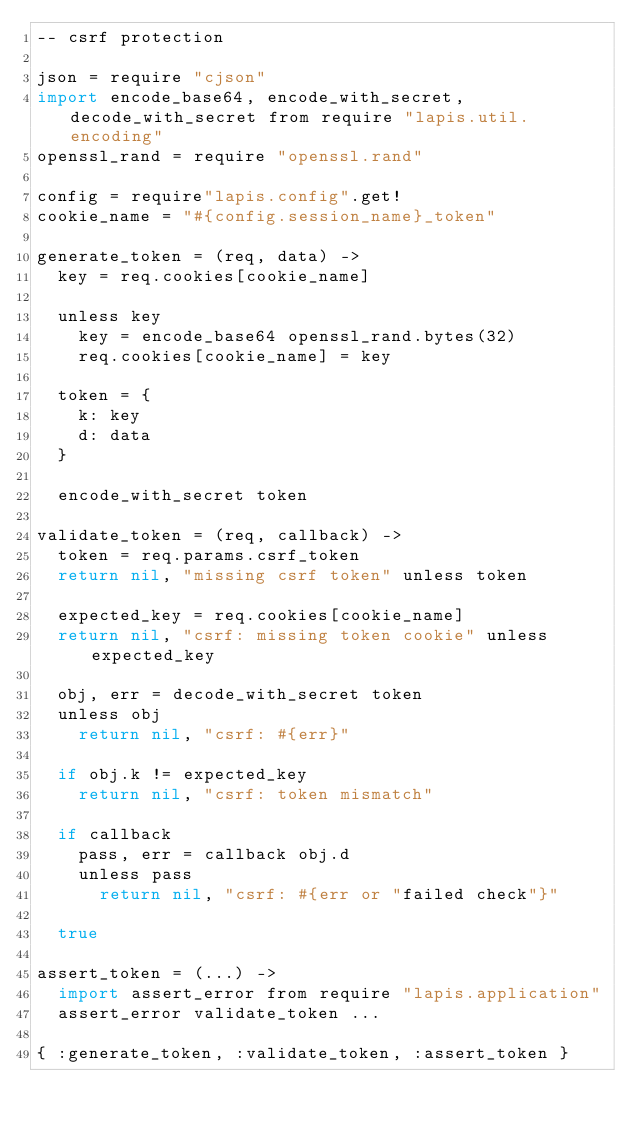<code> <loc_0><loc_0><loc_500><loc_500><_MoonScript_>-- csrf protection

json = require "cjson"
import encode_base64, encode_with_secret, decode_with_secret from require "lapis.util.encoding"
openssl_rand = require "openssl.rand"

config = require"lapis.config".get!
cookie_name = "#{config.session_name}_token"

generate_token = (req, data) ->
  key = req.cookies[cookie_name]

  unless key
    key = encode_base64 openssl_rand.bytes(32)
    req.cookies[cookie_name] = key

  token = {
    k: key
    d: data
  }

  encode_with_secret token

validate_token = (req, callback) ->
  token = req.params.csrf_token
  return nil, "missing csrf token" unless token

  expected_key = req.cookies[cookie_name]
  return nil, "csrf: missing token cookie" unless expected_key

  obj, err = decode_with_secret token
  unless obj
    return nil, "csrf: #{err}"

  if obj.k != expected_key
    return nil, "csrf: token mismatch"

  if callback
    pass, err = callback obj.d
    unless pass
      return nil, "csrf: #{err or "failed check"}"

  true

assert_token = (...) ->
  import assert_error from require "lapis.application"
  assert_error validate_token ...

{ :generate_token, :validate_token, :assert_token }

</code> 